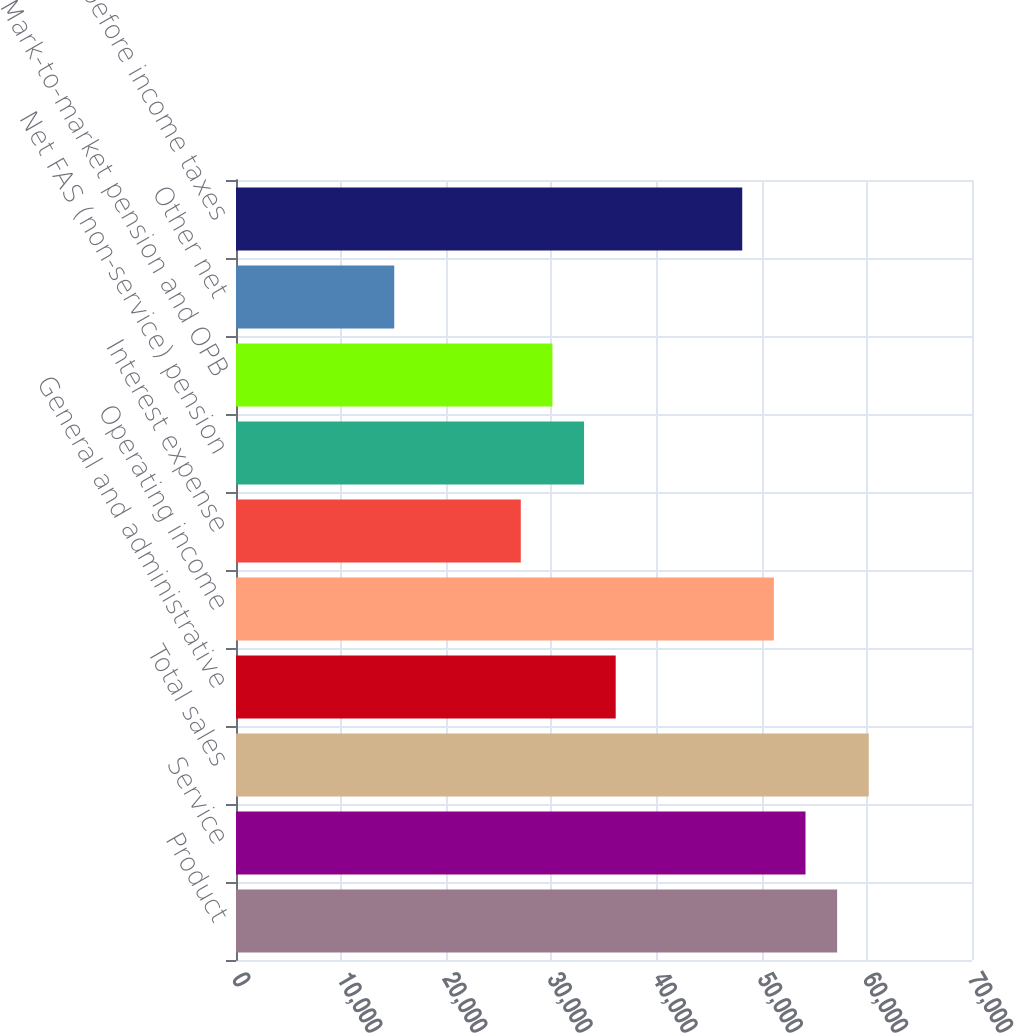Convert chart. <chart><loc_0><loc_0><loc_500><loc_500><bar_chart><fcel>Product<fcel>Service<fcel>Total sales<fcel>General and administrative<fcel>Operating income<fcel>Interest expense<fcel>Net FAS (non-service) pension<fcel>Mark-to-market pension and OPB<fcel>Other net<fcel>Earnings before income taxes<nl><fcel>57173.3<fcel>54164.6<fcel>60182<fcel>36112.4<fcel>51155.9<fcel>27086.3<fcel>33103.7<fcel>30095<fcel>15051.5<fcel>48147.2<nl></chart> 